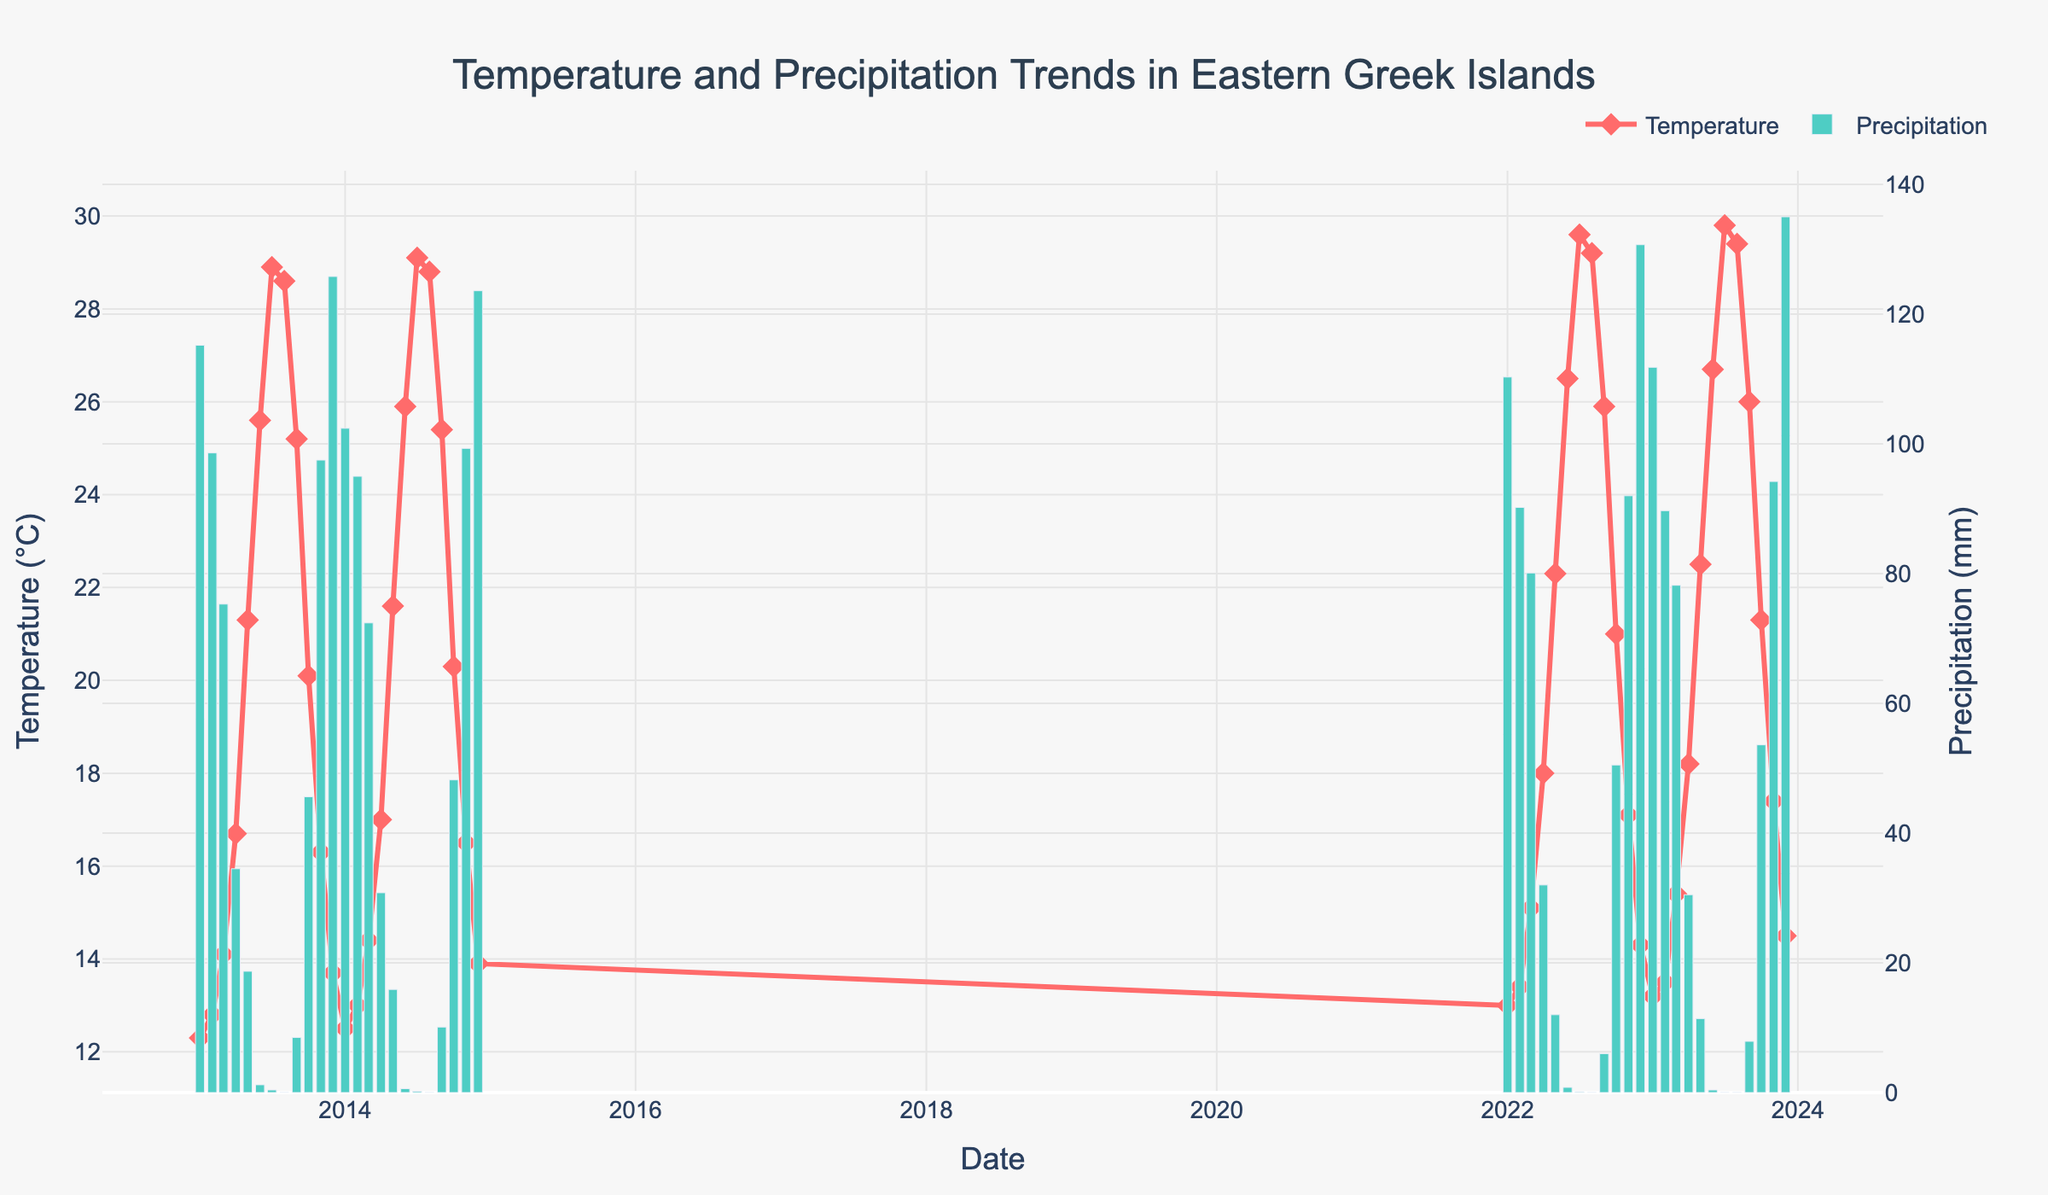What is the title of the figure? The title of the figure is generally found at the top center of the plot. It provides an overview of what the plot represents.
Answer: Temperature and Precipitation Trends in Eastern Greek Islands How many different years of data are visualized in the figure? To determine the number of years, look at the x-axis which represents the dates. Count the distinct years shown. For this plot, the data spans from 2013 to 2023.
Answer: 11 What are the lowest and highest average temperatures recorded in the decade? Identify the lowest and highest points on the line representing average temperature (°C) on the primary y-axis. The lowest temperature is in January 2013, and the highest temperature is in July 2023.
Answer: Lowest: 12.3°C, Highest: 29.8°C How does the precipitation in December 2013 compare to December 2023? Look at the bar heights for December 2013 and December 2023 on the secondary y-axis. December 2013 shows precipitation around 125.8mm, while December 2023 shows about 135mm.
Answer: December 2023 has more precipitation What is the overall trend in average temperature from January to December in each year? Examine the line representing temperature for each year from start (January) to end (December). Typically, temperature increases from winter to summer (June/July) and decreases again towards winter.
Answer: Increasing until July, then decreasing Which month recorded the highest precipitation in the dataset? Look at the bars representing precipitation and identify the highest one. The highest bar is in December 2023.
Answer: December 2023 What is the temperature difference between January 2013 and January 2023? Check the temperature values for January 2013 and January 2023 and calculate the difference: 13.2°C (2023) - 12.3°C (2013) = 0.9°C.
Answer: 0.9°C Which year had the least variation in monthly precipitation? Calculate the difference between the maximum and minimum precipitation values for each year. The year with the smallest difference has the least variation. Calculate this for 2013, 2014, 2022, and 2023.
Answer: 2014 Does the summer (June-August) show any precipitation? Observe the bars for the months of June, July, and August across all years and check if any bars represent precipitation. Most of these bars are close to 0.
Answer: Minimal or almost no precipitation How does the average temperature in 2022 compare to the average temperature in 2013? Calculate the average temperature for each year by summing and averaging the monthly temperatures. Compare the yearly averages: (sum of 2022 temperatures)/12 vs (sum of 2013 temperatures)/12.
Answer: 2022 has a higher average temperature 